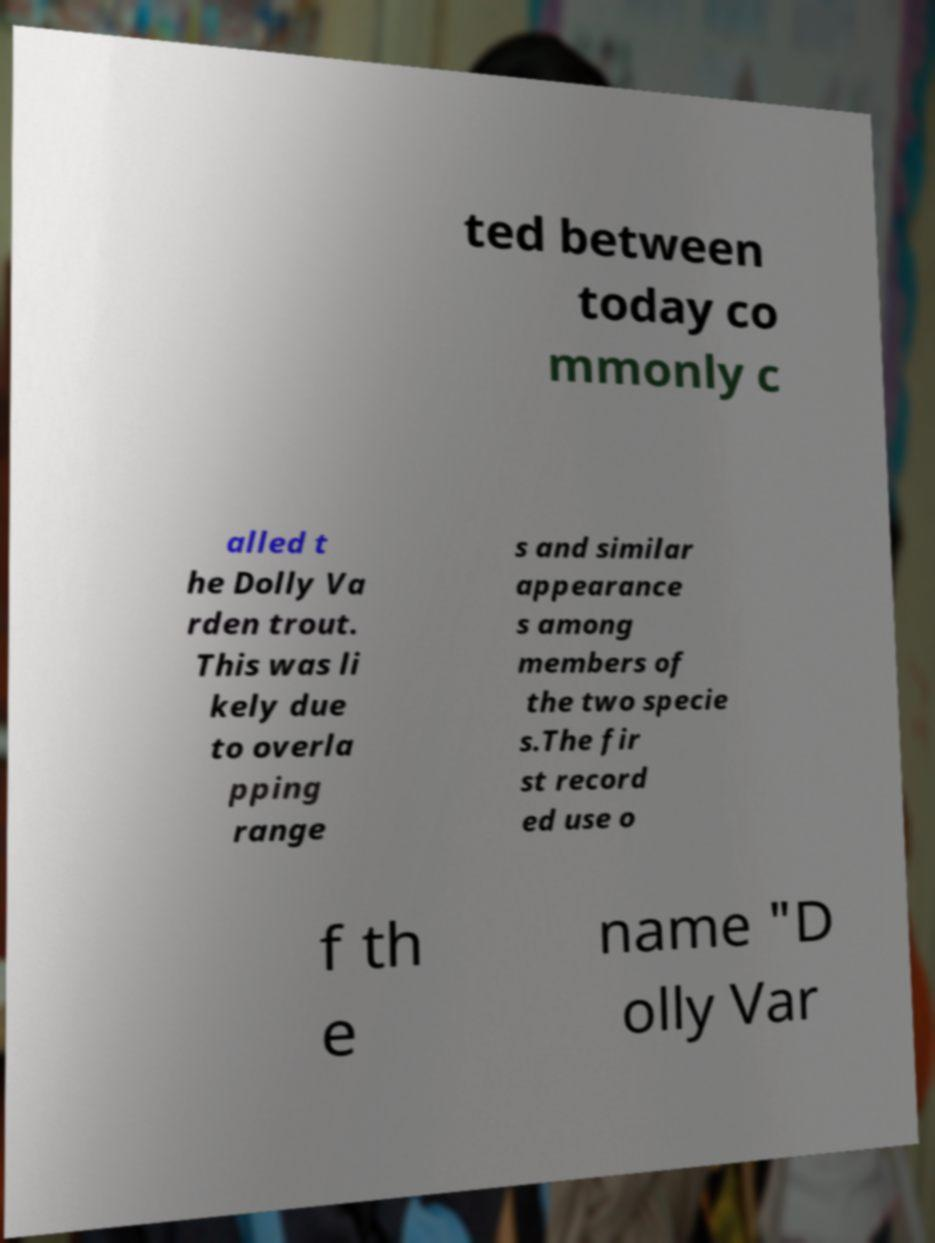I need the written content from this picture converted into text. Can you do that? ted between today co mmonly c alled t he Dolly Va rden trout. This was li kely due to overla pping range s and similar appearance s among members of the two specie s.The fir st record ed use o f th e name "D olly Var 